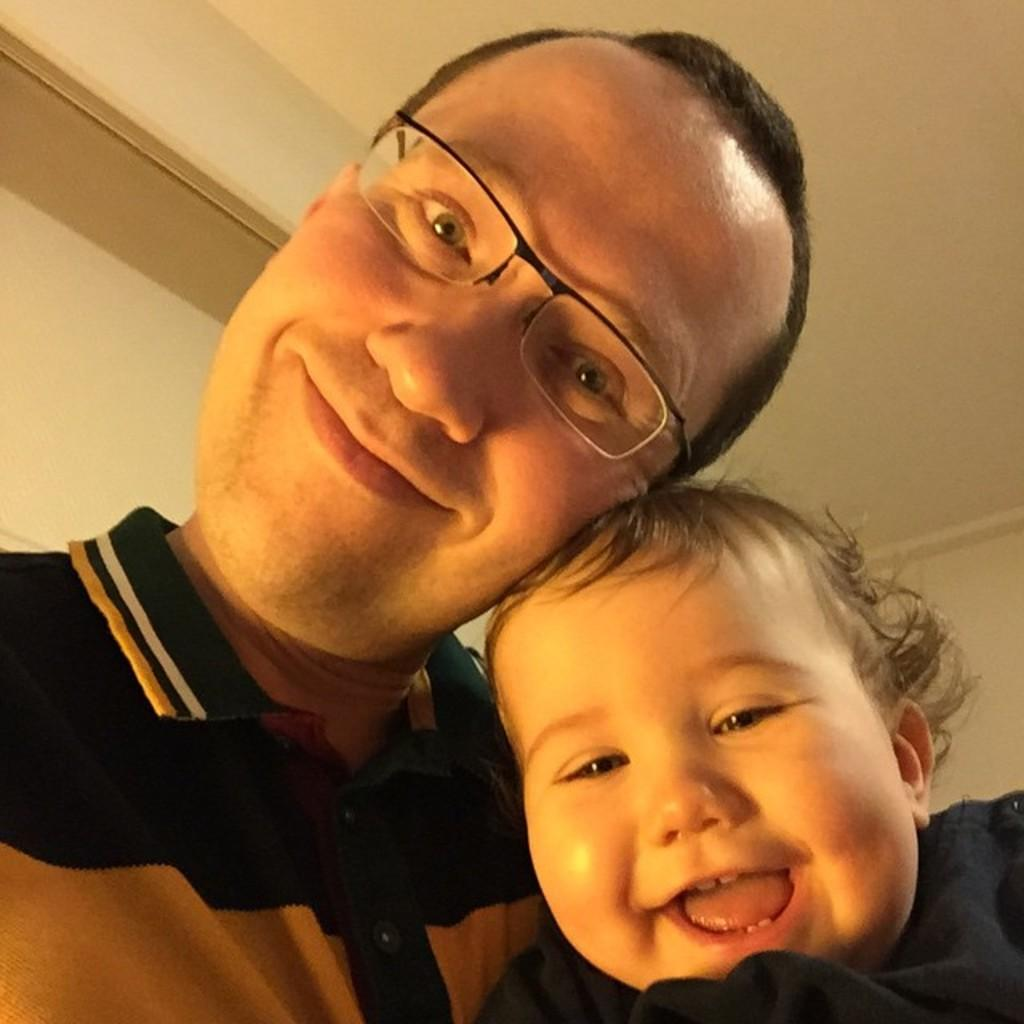What is the main subject of the image? There is a baby in the image. What is the baby doing in the image? The baby is smiling. Who else is present in the image? There is a man with spectacles in the image. What is the man with spectacles doing in the image? The man with spectacles is smiling. What can be seen in the background of the image? There is a wall in the background of the image. What type of jeans is the group wearing in the image? There is no group present in the image, and therefore no jeans can be observed. 